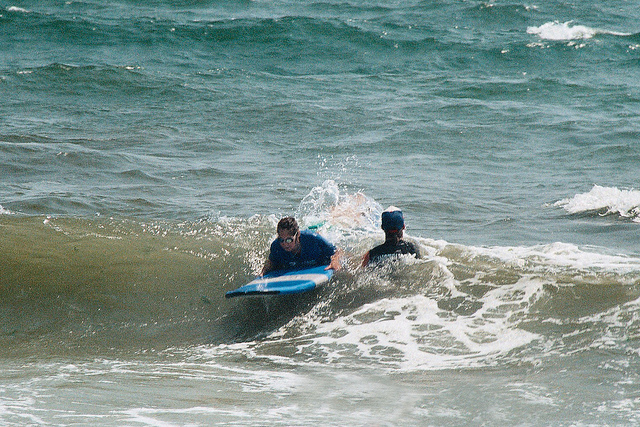<image>What kind of boat is the man floating on? It is unclear what kind of boat the man is floating on, it could be a surfboard. What kind of boat is the man floating on? I don't know what kind of boat the man is floating on. It can be a surfboard or it may not be a boat at all, just a surfboard. 